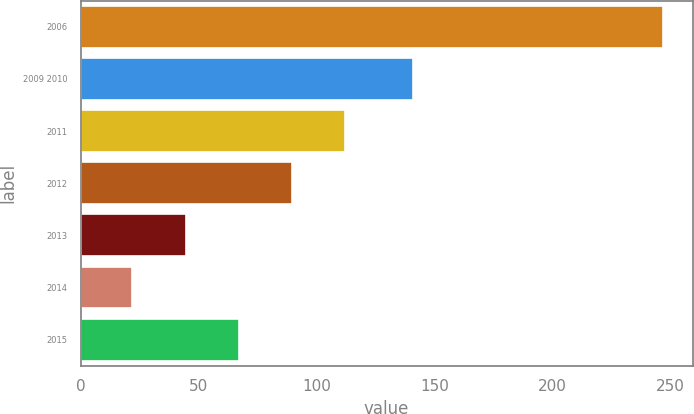Convert chart to OTSL. <chart><loc_0><loc_0><loc_500><loc_500><bar_chart><fcel>2006<fcel>2009 2010<fcel>2011<fcel>2012<fcel>2013<fcel>2014<fcel>2015<nl><fcel>247<fcel>141<fcel>112<fcel>89.5<fcel>44.5<fcel>22<fcel>67<nl></chart> 